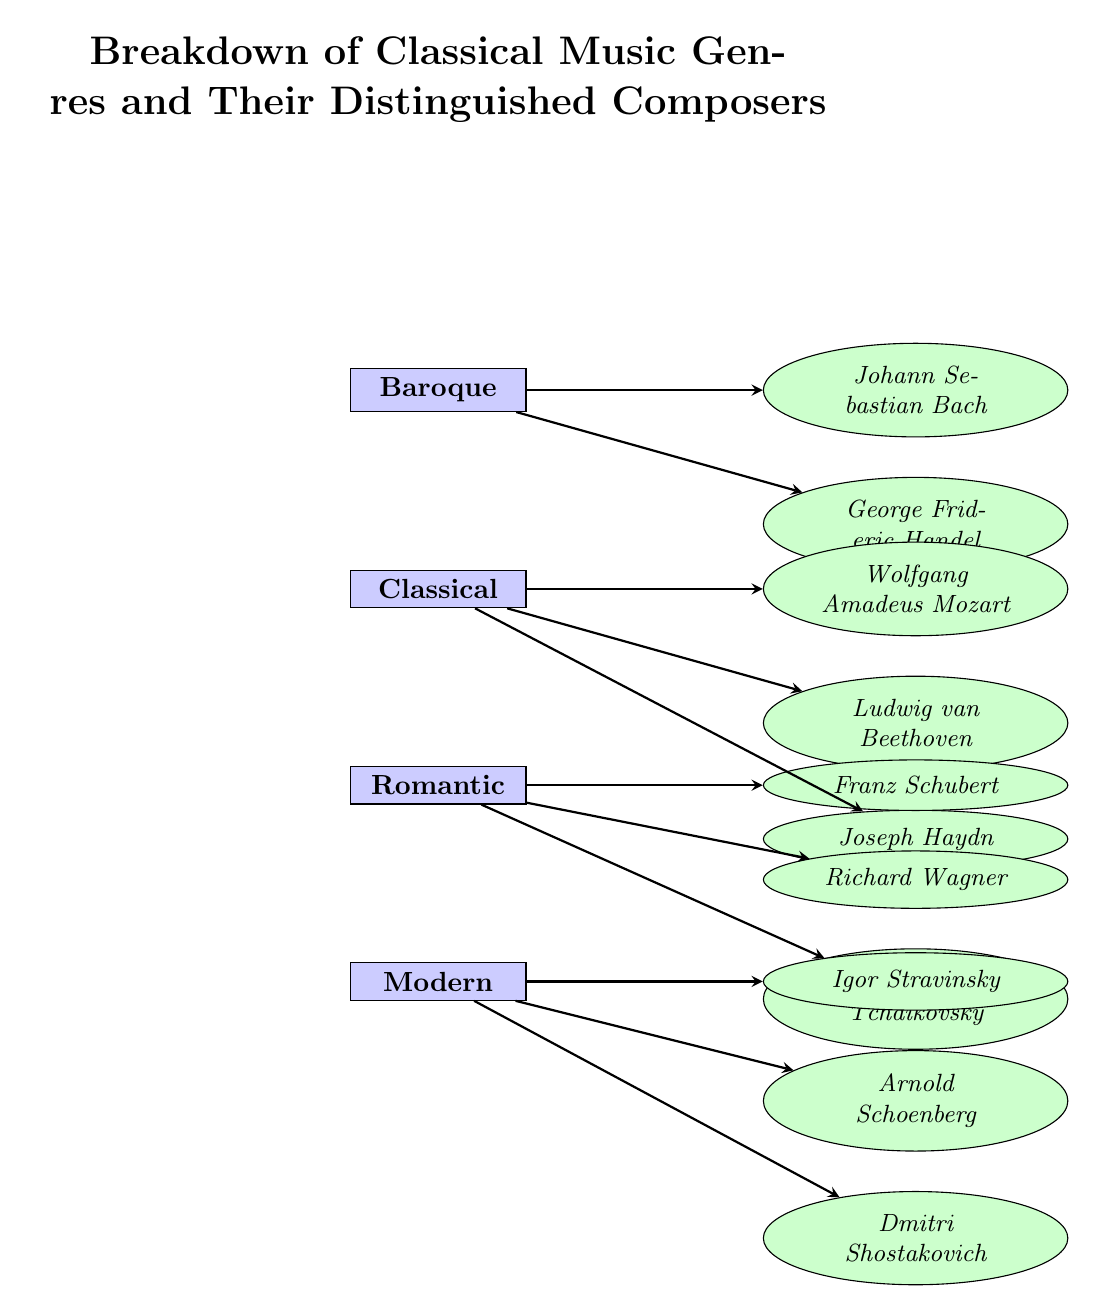What is the lowest classical music genre in the diagram? In the diagram, the genres are stacked from top to bottom, starting with Baroque at the top and ending with Modern at the bottom. The lowest genre is therefore Modern.
Answer: Modern How many composers are listed under the Romantic genre? The Romantic genre has three composers listed: Schubert, Wagner, and Tchaikovsky. Therefore, the count of composers under this genre is three.
Answer: Three Who is the composer associated with the Baroque genre that is listed first? In the diagram, Johann Sebastian Bach is positioned first under the Baroque genre, indicating he is the primary or distinguished composer associated with this genre.
Answer: Johann Sebastian Bach Which genre has Ludwig van Beethoven as a composer? Ludwig van Beethoven is listed directly beneath the Classical genre in the diagram. Therefore, he is associated with the Classical genre.
Answer: Classical How many total genres are depicted in the diagram? The diagram clearly shows four distinct genres: Baroque, Classical, Romantic, and Modern. Counting these, we determine that the total number of genres is four.
Answer: Four Which composer is the only one listed under the Modern genre that starts with 'S'? Within the Modern genre, the composer Arnold Schoenberg is the only one whose name starts with 'S'. Therefore, the composer meeting this criteria is Schoenberg.
Answer: Arnold Schoenberg Which genre has the greatest number of composers listed? By assessing the number of composers associated with each genre, Baroque has two composers, Classical has three, Romantic has three, and Modern has three. Classical, Romantic, and Modern all share the highest count of three composers.
Answer: Classical, Romantic, Modern What is the relationship shown between composers and genres in the diagram? The diagram illustrates a one-to-many relationship where each genre can have multiple associated composers. This relationship is shown with directional arrows leading from each genre node to the composer nodes.
Answer: One-to-many 